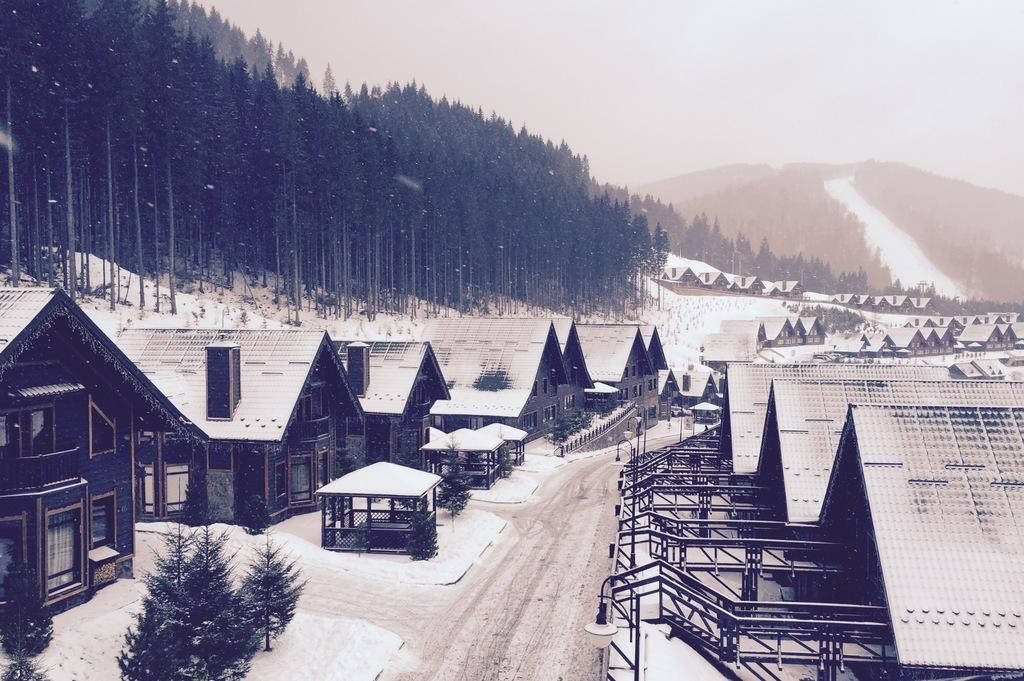What type of structures are present in the image? There are houses in the image. What other natural elements can be seen in the image? There are plants, trees, and a mountain in the image. Are there any man-made objects besides the houses? Yes, there are poles in the image. What can be seen in the background of the image? The sky is visible in the background of the image. Can you see any clams interacting with the houses in the image? There are no clams present in the image. Are there any fairies flying around the trees in the image? There are no fairies present in the image. 